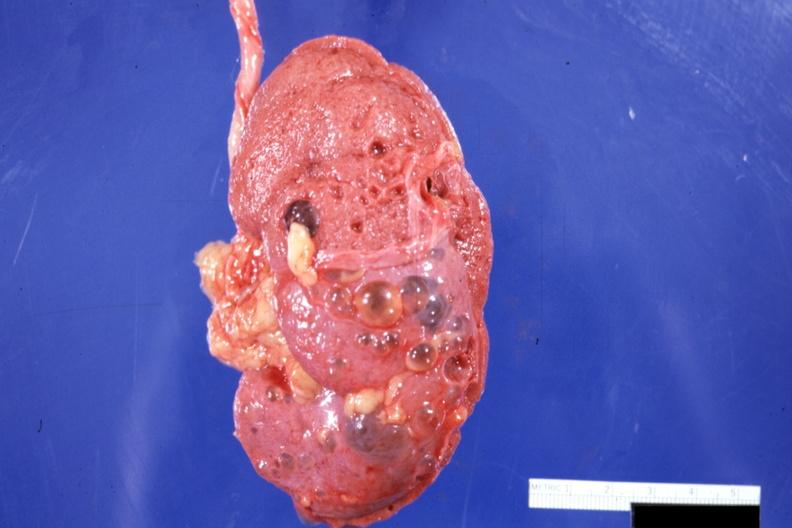s loops present?
Answer the question using a single word or phrase. No 